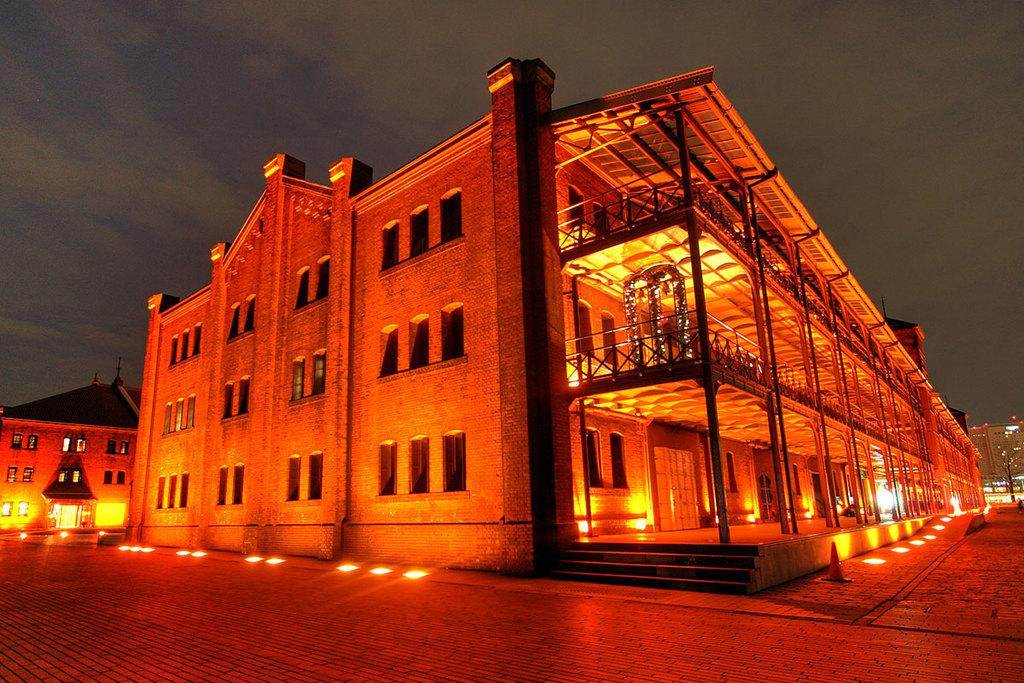What type of structures can be seen in the image? There are buildings in the image. What feature is present on the buildings? There are windows in the image. What can be seen illuminating the buildings? There are lights in the image. How can one access different levels of the buildings? There are stairs in the image. What safety equipment is present in the image? There are traffic cones in the image. What is visible in the background of the image? The sky is visible in the image. What type of cabbage is being used as a chess piece in the image? There is no cabbage or chess piece present in the image. 